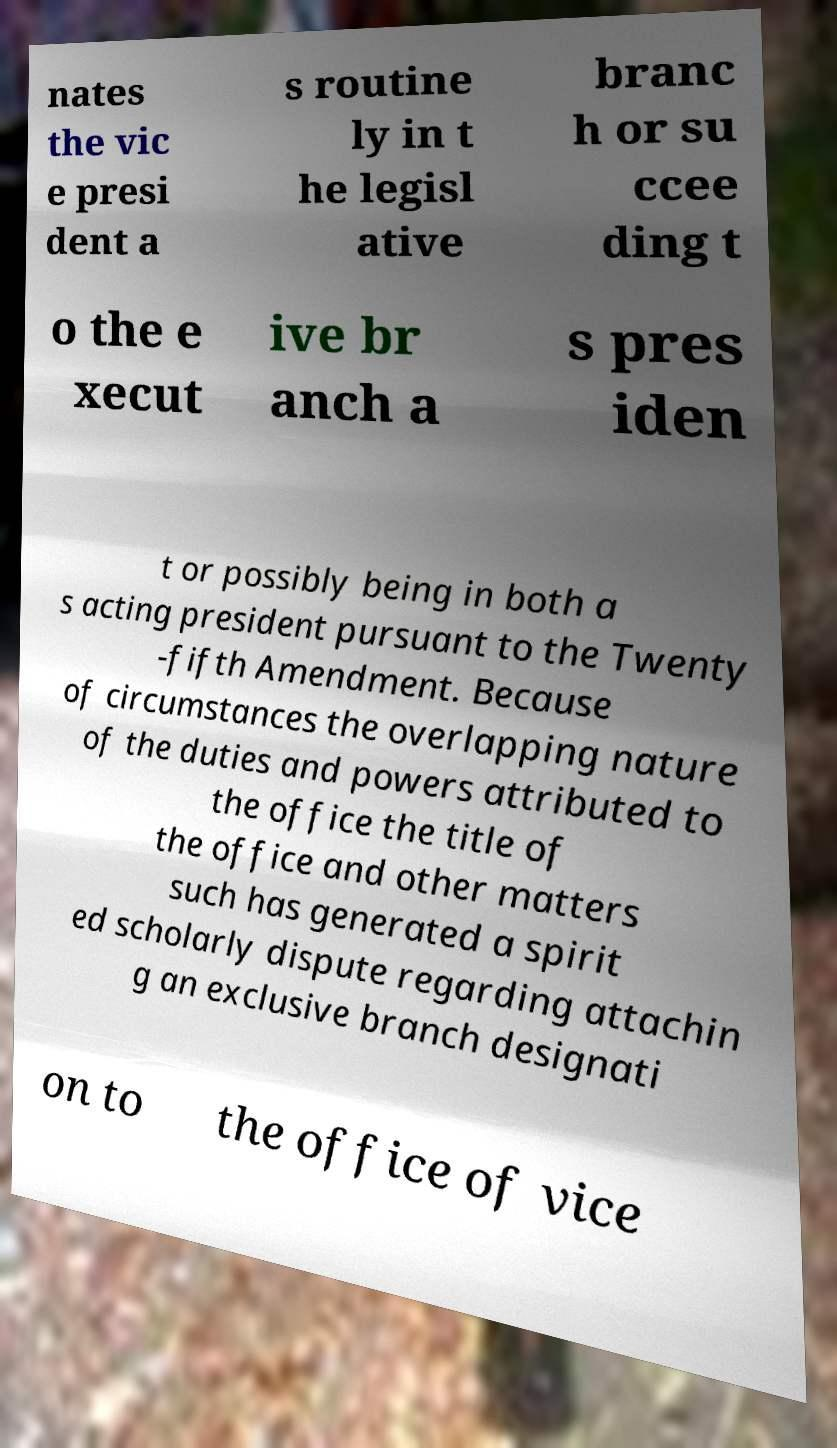For documentation purposes, I need the text within this image transcribed. Could you provide that? nates the vic e presi dent a s routine ly in t he legisl ative branc h or su ccee ding t o the e xecut ive br anch a s pres iden t or possibly being in both a s acting president pursuant to the Twenty -fifth Amendment. Because of circumstances the overlapping nature of the duties and powers attributed to the office the title of the office and other matters such has generated a spirit ed scholarly dispute regarding attachin g an exclusive branch designati on to the office of vice 